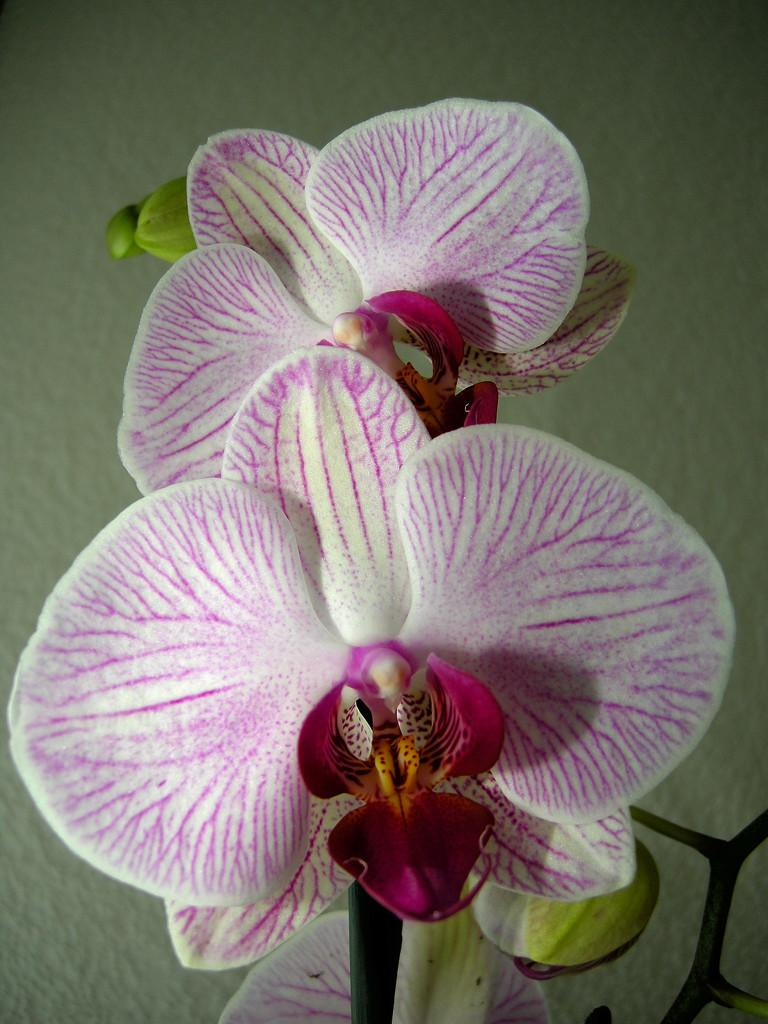What type of living organisms can be seen in the image? There are flowers in the image. What part of the flowers is visible in the image? The flowers belong to a plant, so the stems and possibly leaves are also visible. What can be seen in the background of the image? There is a wall visible in the background of the image. What type of string is used to tie the crow to the flowers in the image? There is no crow or string present in the image; it only features flowers and a wall in the background. 